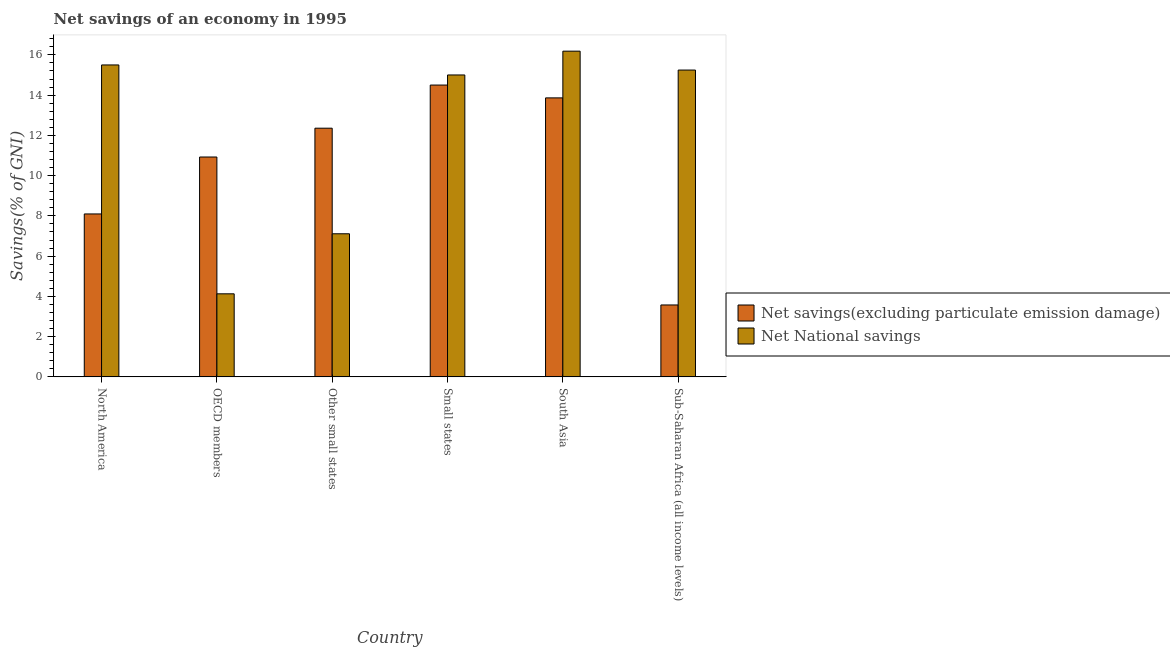Are the number of bars on each tick of the X-axis equal?
Ensure brevity in your answer.  Yes. What is the net savings(excluding particulate emission damage) in Small states?
Your response must be concise. 14.5. Across all countries, what is the maximum net savings(excluding particulate emission damage)?
Your response must be concise. 14.5. Across all countries, what is the minimum net savings(excluding particulate emission damage)?
Your answer should be compact. 3.57. In which country was the net savings(excluding particulate emission damage) maximum?
Your response must be concise. Small states. In which country was the net savings(excluding particulate emission damage) minimum?
Your answer should be very brief. Sub-Saharan Africa (all income levels). What is the total net savings(excluding particulate emission damage) in the graph?
Make the answer very short. 63.32. What is the difference between the net savings(excluding particulate emission damage) in OECD members and that in Small states?
Provide a succinct answer. -3.58. What is the difference between the net savings(excluding particulate emission damage) in OECD members and the net national savings in South Asia?
Keep it short and to the point. -5.26. What is the average net national savings per country?
Offer a very short reply. 12.2. What is the difference between the net national savings and net savings(excluding particulate emission damage) in North America?
Keep it short and to the point. 7.4. What is the ratio of the net savings(excluding particulate emission damage) in OECD members to that in Sub-Saharan Africa (all income levels)?
Your answer should be very brief. 3.06. What is the difference between the highest and the second highest net savings(excluding particulate emission damage)?
Ensure brevity in your answer.  0.64. What is the difference between the highest and the lowest net national savings?
Your response must be concise. 12.06. In how many countries, is the net savings(excluding particulate emission damage) greater than the average net savings(excluding particulate emission damage) taken over all countries?
Give a very brief answer. 4. What does the 2nd bar from the left in Small states represents?
Ensure brevity in your answer.  Net National savings. What does the 1st bar from the right in OECD members represents?
Give a very brief answer. Net National savings. How many countries are there in the graph?
Your response must be concise. 6. Are the values on the major ticks of Y-axis written in scientific E-notation?
Your answer should be very brief. No. Does the graph contain any zero values?
Give a very brief answer. No. How many legend labels are there?
Provide a succinct answer. 2. How are the legend labels stacked?
Ensure brevity in your answer.  Vertical. What is the title of the graph?
Offer a terse response. Net savings of an economy in 1995. What is the label or title of the X-axis?
Your response must be concise. Country. What is the label or title of the Y-axis?
Make the answer very short. Savings(% of GNI). What is the Savings(% of GNI) of Net savings(excluding particulate emission damage) in North America?
Ensure brevity in your answer.  8.1. What is the Savings(% of GNI) of Net National savings in North America?
Ensure brevity in your answer.  15.5. What is the Savings(% of GNI) in Net savings(excluding particulate emission damage) in OECD members?
Give a very brief answer. 10.93. What is the Savings(% of GNI) of Net National savings in OECD members?
Keep it short and to the point. 4.13. What is the Savings(% of GNI) in Net savings(excluding particulate emission damage) in Other small states?
Your answer should be compact. 12.36. What is the Savings(% of GNI) of Net National savings in Other small states?
Provide a short and direct response. 7.11. What is the Savings(% of GNI) in Net savings(excluding particulate emission damage) in Small states?
Give a very brief answer. 14.5. What is the Savings(% of GNI) of Net National savings in Small states?
Keep it short and to the point. 15. What is the Savings(% of GNI) of Net savings(excluding particulate emission damage) in South Asia?
Provide a succinct answer. 13.86. What is the Savings(% of GNI) in Net National savings in South Asia?
Your answer should be compact. 16.19. What is the Savings(% of GNI) of Net savings(excluding particulate emission damage) in Sub-Saharan Africa (all income levels)?
Your response must be concise. 3.57. What is the Savings(% of GNI) of Net National savings in Sub-Saharan Africa (all income levels)?
Ensure brevity in your answer.  15.25. Across all countries, what is the maximum Savings(% of GNI) of Net savings(excluding particulate emission damage)?
Your response must be concise. 14.5. Across all countries, what is the maximum Savings(% of GNI) of Net National savings?
Give a very brief answer. 16.19. Across all countries, what is the minimum Savings(% of GNI) in Net savings(excluding particulate emission damage)?
Your answer should be compact. 3.57. Across all countries, what is the minimum Savings(% of GNI) in Net National savings?
Your response must be concise. 4.13. What is the total Savings(% of GNI) of Net savings(excluding particulate emission damage) in the graph?
Keep it short and to the point. 63.32. What is the total Savings(% of GNI) in Net National savings in the graph?
Your response must be concise. 73.17. What is the difference between the Savings(% of GNI) of Net savings(excluding particulate emission damage) in North America and that in OECD members?
Make the answer very short. -2.83. What is the difference between the Savings(% of GNI) in Net National savings in North America and that in OECD members?
Provide a succinct answer. 11.37. What is the difference between the Savings(% of GNI) in Net savings(excluding particulate emission damage) in North America and that in Other small states?
Offer a very short reply. -4.26. What is the difference between the Savings(% of GNI) of Net National savings in North America and that in Other small states?
Your answer should be very brief. 8.39. What is the difference between the Savings(% of GNI) of Net savings(excluding particulate emission damage) in North America and that in Small states?
Provide a succinct answer. -6.41. What is the difference between the Savings(% of GNI) of Net National savings in North America and that in Small states?
Keep it short and to the point. 0.5. What is the difference between the Savings(% of GNI) in Net savings(excluding particulate emission damage) in North America and that in South Asia?
Make the answer very short. -5.77. What is the difference between the Savings(% of GNI) of Net National savings in North America and that in South Asia?
Your answer should be compact. -0.69. What is the difference between the Savings(% of GNI) in Net savings(excluding particulate emission damage) in North America and that in Sub-Saharan Africa (all income levels)?
Keep it short and to the point. 4.52. What is the difference between the Savings(% of GNI) in Net National savings in North America and that in Sub-Saharan Africa (all income levels)?
Make the answer very short. 0.25. What is the difference between the Savings(% of GNI) of Net savings(excluding particulate emission damage) in OECD members and that in Other small states?
Your response must be concise. -1.43. What is the difference between the Savings(% of GNI) of Net National savings in OECD members and that in Other small states?
Your answer should be compact. -2.98. What is the difference between the Savings(% of GNI) in Net savings(excluding particulate emission damage) in OECD members and that in Small states?
Offer a very short reply. -3.58. What is the difference between the Savings(% of GNI) of Net National savings in OECD members and that in Small states?
Offer a terse response. -10.88. What is the difference between the Savings(% of GNI) of Net savings(excluding particulate emission damage) in OECD members and that in South Asia?
Your response must be concise. -2.94. What is the difference between the Savings(% of GNI) in Net National savings in OECD members and that in South Asia?
Your answer should be compact. -12.06. What is the difference between the Savings(% of GNI) of Net savings(excluding particulate emission damage) in OECD members and that in Sub-Saharan Africa (all income levels)?
Give a very brief answer. 7.35. What is the difference between the Savings(% of GNI) in Net National savings in OECD members and that in Sub-Saharan Africa (all income levels)?
Provide a short and direct response. -11.12. What is the difference between the Savings(% of GNI) of Net savings(excluding particulate emission damage) in Other small states and that in Small states?
Give a very brief answer. -2.14. What is the difference between the Savings(% of GNI) of Net National savings in Other small states and that in Small states?
Your response must be concise. -7.89. What is the difference between the Savings(% of GNI) of Net savings(excluding particulate emission damage) in Other small states and that in South Asia?
Ensure brevity in your answer.  -1.51. What is the difference between the Savings(% of GNI) of Net National savings in Other small states and that in South Asia?
Keep it short and to the point. -9.07. What is the difference between the Savings(% of GNI) in Net savings(excluding particulate emission damage) in Other small states and that in Sub-Saharan Africa (all income levels)?
Ensure brevity in your answer.  8.78. What is the difference between the Savings(% of GNI) in Net National savings in Other small states and that in Sub-Saharan Africa (all income levels)?
Keep it short and to the point. -8.14. What is the difference between the Savings(% of GNI) in Net savings(excluding particulate emission damage) in Small states and that in South Asia?
Your answer should be compact. 0.64. What is the difference between the Savings(% of GNI) of Net National savings in Small states and that in South Asia?
Offer a very short reply. -1.18. What is the difference between the Savings(% of GNI) of Net savings(excluding particulate emission damage) in Small states and that in Sub-Saharan Africa (all income levels)?
Ensure brevity in your answer.  10.93. What is the difference between the Savings(% of GNI) in Net National savings in Small states and that in Sub-Saharan Africa (all income levels)?
Give a very brief answer. -0.24. What is the difference between the Savings(% of GNI) of Net savings(excluding particulate emission damage) in South Asia and that in Sub-Saharan Africa (all income levels)?
Your response must be concise. 10.29. What is the difference between the Savings(% of GNI) of Net National savings in South Asia and that in Sub-Saharan Africa (all income levels)?
Offer a terse response. 0.94. What is the difference between the Savings(% of GNI) of Net savings(excluding particulate emission damage) in North America and the Savings(% of GNI) of Net National savings in OECD members?
Give a very brief answer. 3.97. What is the difference between the Savings(% of GNI) in Net savings(excluding particulate emission damage) in North America and the Savings(% of GNI) in Net National savings in Other small states?
Make the answer very short. 0.99. What is the difference between the Savings(% of GNI) in Net savings(excluding particulate emission damage) in North America and the Savings(% of GNI) in Net National savings in Small states?
Give a very brief answer. -6.91. What is the difference between the Savings(% of GNI) of Net savings(excluding particulate emission damage) in North America and the Savings(% of GNI) of Net National savings in South Asia?
Give a very brief answer. -8.09. What is the difference between the Savings(% of GNI) in Net savings(excluding particulate emission damage) in North America and the Savings(% of GNI) in Net National savings in Sub-Saharan Africa (all income levels)?
Make the answer very short. -7.15. What is the difference between the Savings(% of GNI) of Net savings(excluding particulate emission damage) in OECD members and the Savings(% of GNI) of Net National savings in Other small states?
Your answer should be compact. 3.82. What is the difference between the Savings(% of GNI) of Net savings(excluding particulate emission damage) in OECD members and the Savings(% of GNI) of Net National savings in Small states?
Give a very brief answer. -4.08. What is the difference between the Savings(% of GNI) in Net savings(excluding particulate emission damage) in OECD members and the Savings(% of GNI) in Net National savings in South Asia?
Make the answer very short. -5.26. What is the difference between the Savings(% of GNI) of Net savings(excluding particulate emission damage) in OECD members and the Savings(% of GNI) of Net National savings in Sub-Saharan Africa (all income levels)?
Give a very brief answer. -4.32. What is the difference between the Savings(% of GNI) in Net savings(excluding particulate emission damage) in Other small states and the Savings(% of GNI) in Net National savings in Small states?
Your answer should be compact. -2.65. What is the difference between the Savings(% of GNI) in Net savings(excluding particulate emission damage) in Other small states and the Savings(% of GNI) in Net National savings in South Asia?
Offer a terse response. -3.83. What is the difference between the Savings(% of GNI) in Net savings(excluding particulate emission damage) in Other small states and the Savings(% of GNI) in Net National savings in Sub-Saharan Africa (all income levels)?
Give a very brief answer. -2.89. What is the difference between the Savings(% of GNI) in Net savings(excluding particulate emission damage) in Small states and the Savings(% of GNI) in Net National savings in South Asia?
Your answer should be very brief. -1.68. What is the difference between the Savings(% of GNI) of Net savings(excluding particulate emission damage) in Small states and the Savings(% of GNI) of Net National savings in Sub-Saharan Africa (all income levels)?
Give a very brief answer. -0.75. What is the difference between the Savings(% of GNI) in Net savings(excluding particulate emission damage) in South Asia and the Savings(% of GNI) in Net National savings in Sub-Saharan Africa (all income levels)?
Offer a very short reply. -1.38. What is the average Savings(% of GNI) of Net savings(excluding particulate emission damage) per country?
Give a very brief answer. 10.55. What is the average Savings(% of GNI) of Net National savings per country?
Give a very brief answer. 12.2. What is the difference between the Savings(% of GNI) of Net savings(excluding particulate emission damage) and Savings(% of GNI) of Net National savings in North America?
Give a very brief answer. -7.4. What is the difference between the Savings(% of GNI) of Net savings(excluding particulate emission damage) and Savings(% of GNI) of Net National savings in OECD members?
Make the answer very short. 6.8. What is the difference between the Savings(% of GNI) in Net savings(excluding particulate emission damage) and Savings(% of GNI) in Net National savings in Other small states?
Your answer should be compact. 5.25. What is the difference between the Savings(% of GNI) in Net savings(excluding particulate emission damage) and Savings(% of GNI) in Net National savings in Small states?
Your answer should be compact. -0.5. What is the difference between the Savings(% of GNI) of Net savings(excluding particulate emission damage) and Savings(% of GNI) of Net National savings in South Asia?
Provide a short and direct response. -2.32. What is the difference between the Savings(% of GNI) in Net savings(excluding particulate emission damage) and Savings(% of GNI) in Net National savings in Sub-Saharan Africa (all income levels)?
Ensure brevity in your answer.  -11.67. What is the ratio of the Savings(% of GNI) of Net savings(excluding particulate emission damage) in North America to that in OECD members?
Offer a terse response. 0.74. What is the ratio of the Savings(% of GNI) in Net National savings in North America to that in OECD members?
Your answer should be compact. 3.76. What is the ratio of the Savings(% of GNI) in Net savings(excluding particulate emission damage) in North America to that in Other small states?
Your answer should be compact. 0.66. What is the ratio of the Savings(% of GNI) of Net National savings in North America to that in Other small states?
Your answer should be very brief. 2.18. What is the ratio of the Savings(% of GNI) of Net savings(excluding particulate emission damage) in North America to that in Small states?
Give a very brief answer. 0.56. What is the ratio of the Savings(% of GNI) in Net National savings in North America to that in Small states?
Your response must be concise. 1.03. What is the ratio of the Savings(% of GNI) of Net savings(excluding particulate emission damage) in North America to that in South Asia?
Keep it short and to the point. 0.58. What is the ratio of the Savings(% of GNI) in Net National savings in North America to that in South Asia?
Keep it short and to the point. 0.96. What is the ratio of the Savings(% of GNI) in Net savings(excluding particulate emission damage) in North America to that in Sub-Saharan Africa (all income levels)?
Your answer should be compact. 2.27. What is the ratio of the Savings(% of GNI) in Net National savings in North America to that in Sub-Saharan Africa (all income levels)?
Your response must be concise. 1.02. What is the ratio of the Savings(% of GNI) in Net savings(excluding particulate emission damage) in OECD members to that in Other small states?
Give a very brief answer. 0.88. What is the ratio of the Savings(% of GNI) of Net National savings in OECD members to that in Other small states?
Keep it short and to the point. 0.58. What is the ratio of the Savings(% of GNI) of Net savings(excluding particulate emission damage) in OECD members to that in Small states?
Ensure brevity in your answer.  0.75. What is the ratio of the Savings(% of GNI) of Net National savings in OECD members to that in Small states?
Provide a succinct answer. 0.28. What is the ratio of the Savings(% of GNI) in Net savings(excluding particulate emission damage) in OECD members to that in South Asia?
Give a very brief answer. 0.79. What is the ratio of the Savings(% of GNI) in Net National savings in OECD members to that in South Asia?
Your answer should be very brief. 0.26. What is the ratio of the Savings(% of GNI) in Net savings(excluding particulate emission damage) in OECD members to that in Sub-Saharan Africa (all income levels)?
Provide a succinct answer. 3.06. What is the ratio of the Savings(% of GNI) in Net National savings in OECD members to that in Sub-Saharan Africa (all income levels)?
Ensure brevity in your answer.  0.27. What is the ratio of the Savings(% of GNI) in Net savings(excluding particulate emission damage) in Other small states to that in Small states?
Your answer should be very brief. 0.85. What is the ratio of the Savings(% of GNI) of Net National savings in Other small states to that in Small states?
Make the answer very short. 0.47. What is the ratio of the Savings(% of GNI) of Net savings(excluding particulate emission damage) in Other small states to that in South Asia?
Keep it short and to the point. 0.89. What is the ratio of the Savings(% of GNI) in Net National savings in Other small states to that in South Asia?
Make the answer very short. 0.44. What is the ratio of the Savings(% of GNI) in Net savings(excluding particulate emission damage) in Other small states to that in Sub-Saharan Africa (all income levels)?
Offer a terse response. 3.46. What is the ratio of the Savings(% of GNI) of Net National savings in Other small states to that in Sub-Saharan Africa (all income levels)?
Provide a succinct answer. 0.47. What is the ratio of the Savings(% of GNI) of Net savings(excluding particulate emission damage) in Small states to that in South Asia?
Keep it short and to the point. 1.05. What is the ratio of the Savings(% of GNI) of Net National savings in Small states to that in South Asia?
Provide a short and direct response. 0.93. What is the ratio of the Savings(% of GNI) of Net savings(excluding particulate emission damage) in Small states to that in Sub-Saharan Africa (all income levels)?
Your answer should be compact. 4.06. What is the ratio of the Savings(% of GNI) of Net savings(excluding particulate emission damage) in South Asia to that in Sub-Saharan Africa (all income levels)?
Give a very brief answer. 3.88. What is the ratio of the Savings(% of GNI) in Net National savings in South Asia to that in Sub-Saharan Africa (all income levels)?
Your answer should be very brief. 1.06. What is the difference between the highest and the second highest Savings(% of GNI) of Net savings(excluding particulate emission damage)?
Provide a short and direct response. 0.64. What is the difference between the highest and the second highest Savings(% of GNI) of Net National savings?
Provide a short and direct response. 0.69. What is the difference between the highest and the lowest Savings(% of GNI) in Net savings(excluding particulate emission damage)?
Offer a very short reply. 10.93. What is the difference between the highest and the lowest Savings(% of GNI) of Net National savings?
Ensure brevity in your answer.  12.06. 